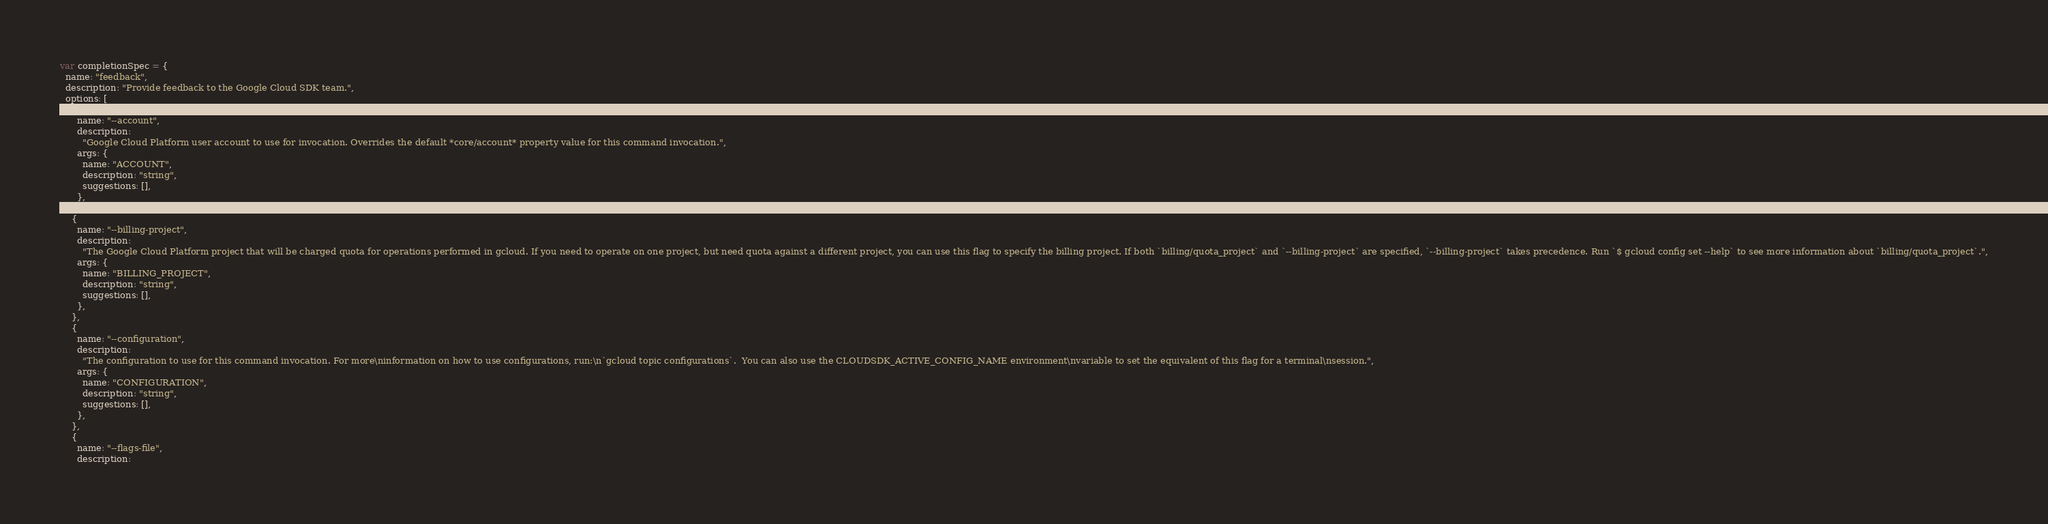Convert code to text. <code><loc_0><loc_0><loc_500><loc_500><_JavaScript_>var completionSpec = {
  name: "feedback",
  description: "Provide feedback to the Google Cloud SDK team.",
  options: [
    {
      name: "--account",
      description:
        "Google Cloud Platform user account to use for invocation. Overrides the default *core/account* property value for this command invocation.",
      args: {
        name: "ACCOUNT",
        description: "string",
        suggestions: [],
      },
    },
    {
      name: "--billing-project",
      description:
        "The Google Cloud Platform project that will be charged quota for operations performed in gcloud. If you need to operate on one project, but need quota against a different project, you can use this flag to specify the billing project. If both `billing/quota_project` and `--billing-project` are specified, `--billing-project` takes precedence. Run `$ gcloud config set --help` to see more information about `billing/quota_project`.",
      args: {
        name: "BILLING_PROJECT",
        description: "string",
        suggestions: [],
      },
    },
    {
      name: "--configuration",
      description:
        "The configuration to use for this command invocation. For more\ninformation on how to use configurations, run:\n`gcloud topic configurations`.  You can also use the CLOUDSDK_ACTIVE_CONFIG_NAME environment\nvariable to set the equivalent of this flag for a terminal\nsession.",
      args: {
        name: "CONFIGURATION",
        description: "string",
        suggestions: [],
      },
    },
    {
      name: "--flags-file",
      description:</code> 